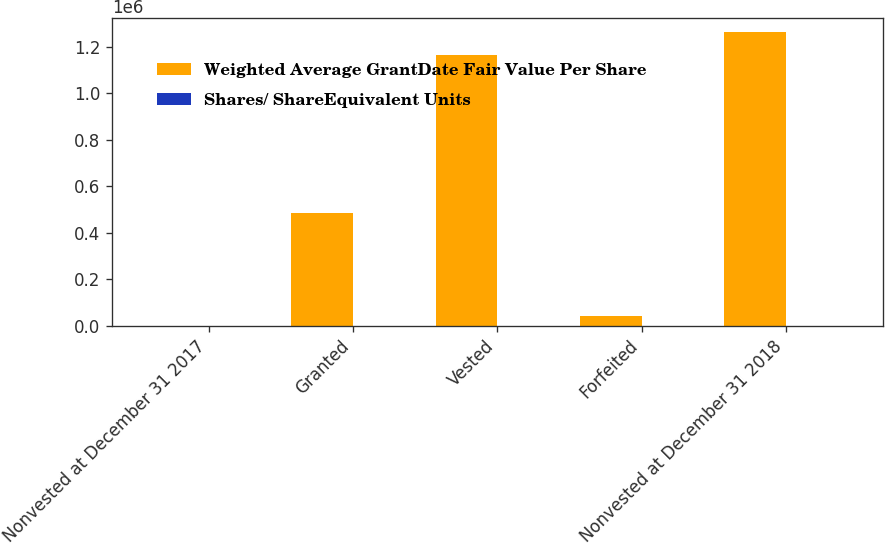Convert chart. <chart><loc_0><loc_0><loc_500><loc_500><stacked_bar_chart><ecel><fcel>Nonvested at December 31 2017<fcel>Granted<fcel>Vested<fcel>Forfeited<fcel>Nonvested at December 31 2018<nl><fcel>Weighted Average GrantDate Fair Value Per Share<fcel>204.97<fcel>482700<fcel>1.1637e+06<fcel>39895<fcel>1.26228e+06<nl><fcel>Shares/ ShareEquivalent Units<fcel>135.38<fcel>204.97<fcel>122.59<fcel>195.99<fcel>171.62<nl></chart> 